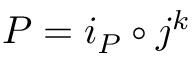<formula> <loc_0><loc_0><loc_500><loc_500>P = i _ { P } \circ j ^ { k }</formula> 